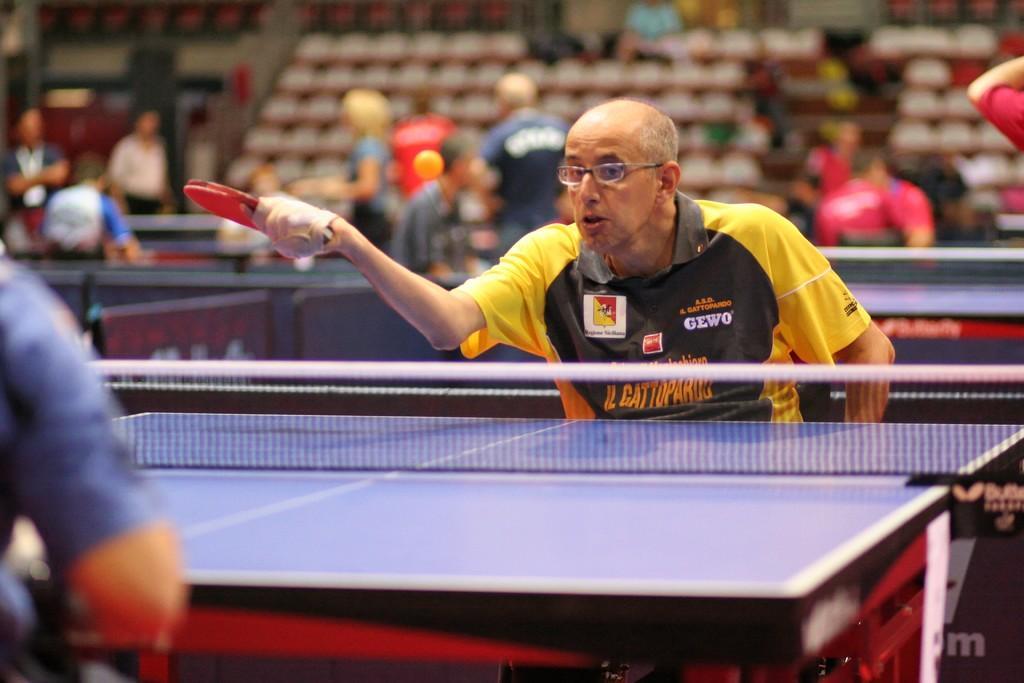Can you describe this image briefly? A man is dressed in black and yellow is playing table tennis and his hand is tied to the hand. In the background we observe many unoccupied chairs and few people spectating the game. There is also an opponent who is opposite to this guy. 